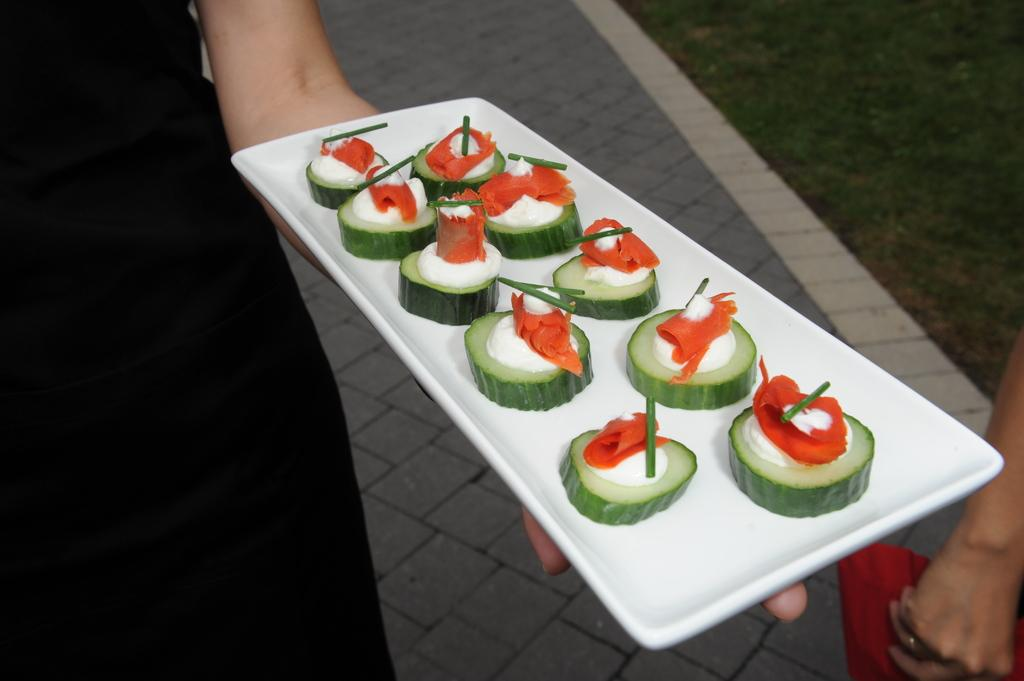How many people are in the image? There are two people in the image. What are the people wearing? Both people are wearing clothes. What is the person on the left side holding? The person on the left side is holding a plate. What shape is the plate? The plate is in a rectangle shape. What can be found on the plate? There is a food item on the plate. Can you tell me what type of ear the person on the right side has in the image? There is no mention of an ear in the image; the focus is on the people, their clothes, and the plate with a food item. 